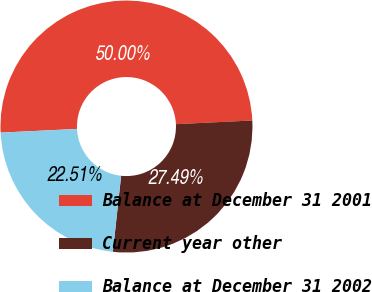Convert chart to OTSL. <chart><loc_0><loc_0><loc_500><loc_500><pie_chart><fcel>Balance at December 31 2001<fcel>Current year other<fcel>Balance at December 31 2002<nl><fcel>50.0%<fcel>27.49%<fcel>22.51%<nl></chart> 